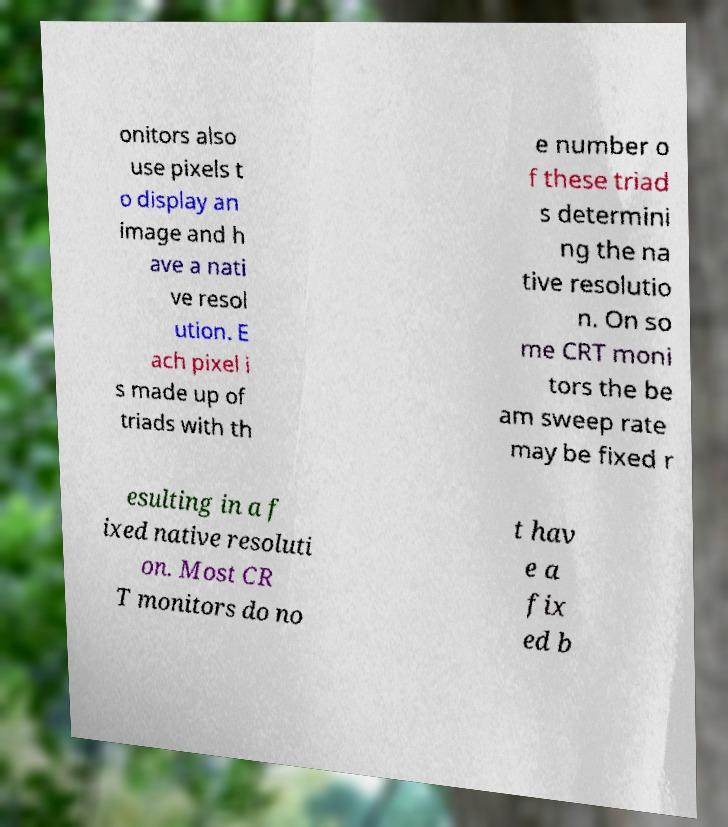For documentation purposes, I need the text within this image transcribed. Could you provide that? onitors also use pixels t o display an image and h ave a nati ve resol ution. E ach pixel i s made up of triads with th e number o f these triad s determini ng the na tive resolutio n. On so me CRT moni tors the be am sweep rate may be fixed r esulting in a f ixed native resoluti on. Most CR T monitors do no t hav e a fix ed b 